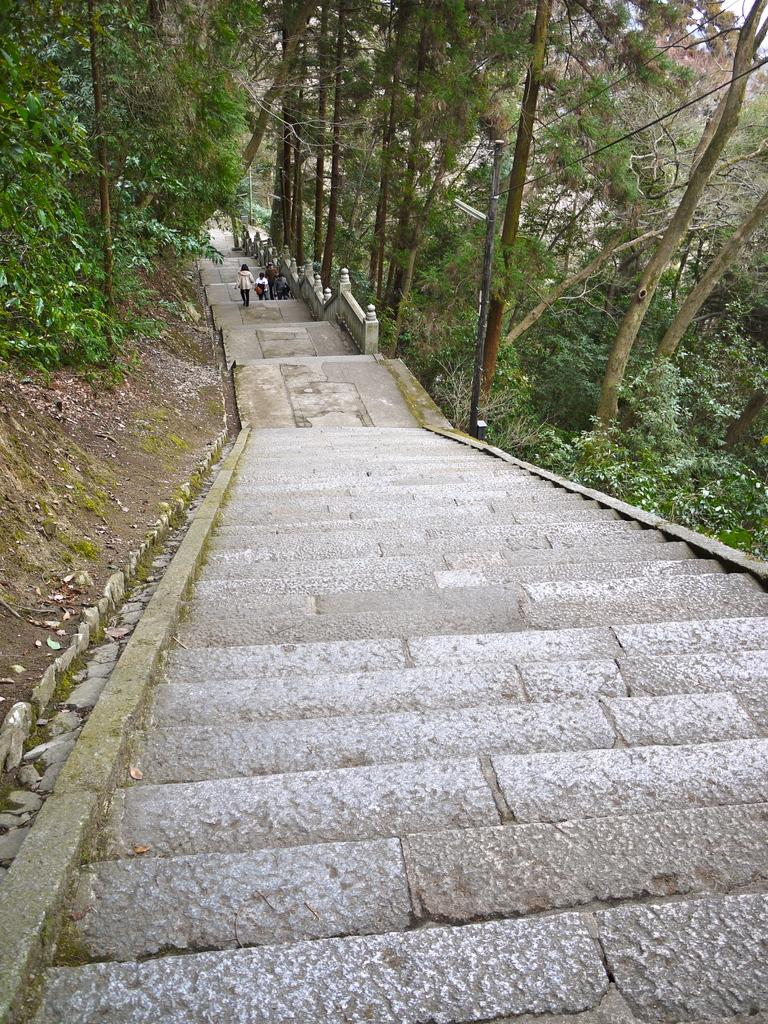Where was the image taken? The image is clicked outside. What can be seen in the center of the image? There is a stairway in the center of the image. Can you describe the people in the image? There is a group of persons in the image. What type of vegetation is present on both sides of the image? There are plants and trees on both sides of the image. What type of music is being played in the background of the image? There is no indication of music being played in the image, as it only shows a stairway, a group of persons, and vegetation. Can you tell me how many jelly containers are visible in the image? There are no jelly containers present in the image. 